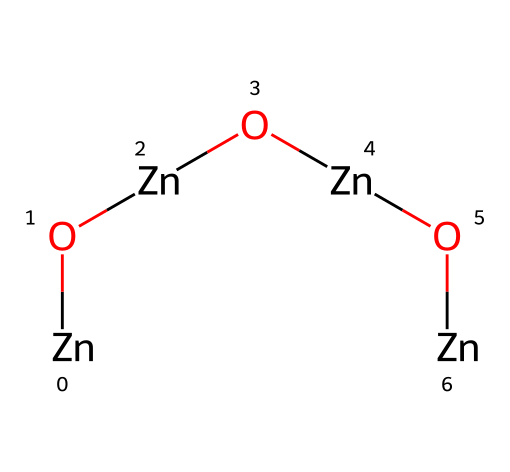What is the molecular formula represented by this SMILES? The SMILES notation indicates a series of zinc (Zn) and oxygen (O) atoms. By counting the occurrence of each element in the SMILES, there are four zinc atoms and three oxygen atoms, leading to the molecular formula Zn4O3.
Answer: Zn4O3 How many zinc atoms are present in this structure? The SMILES notation contains four occurrences of the [Zn] atom, indicating there are four zinc atoms in the structure.
Answer: four What is the total number of oxygen atoms in this molecular structure? By examining the SMILES representation, [O] appears three times, so there are a total of three oxygen atoms in the chemical.
Answer: three What type of bonding can be inferred from the arrangement of zinc and oxygen in this structure? The alternating arrangement of zinc and oxygen suggests ionic bonding due to the presence of metallic zinc and non-metallic oxygen, typical in metal-oxide compounds.
Answer: ionic What is the significance of zinc oxide quantum dots in security tagging? Zinc oxide quantum dots possess unique optical properties that can enhance the visibility and traceability of security tags, making them useful for anti-counterfeiting measures and theft prevention.
Answer: optical properties What does the quantum dot synthesis indicate about potential applications in technology? The synthesis of zinc oxide quantum dots suggests they can be used in photonics and electronics due to their ability to emit light at specific wavelengths, which is beneficial for various technological applications.
Answer: photonics 